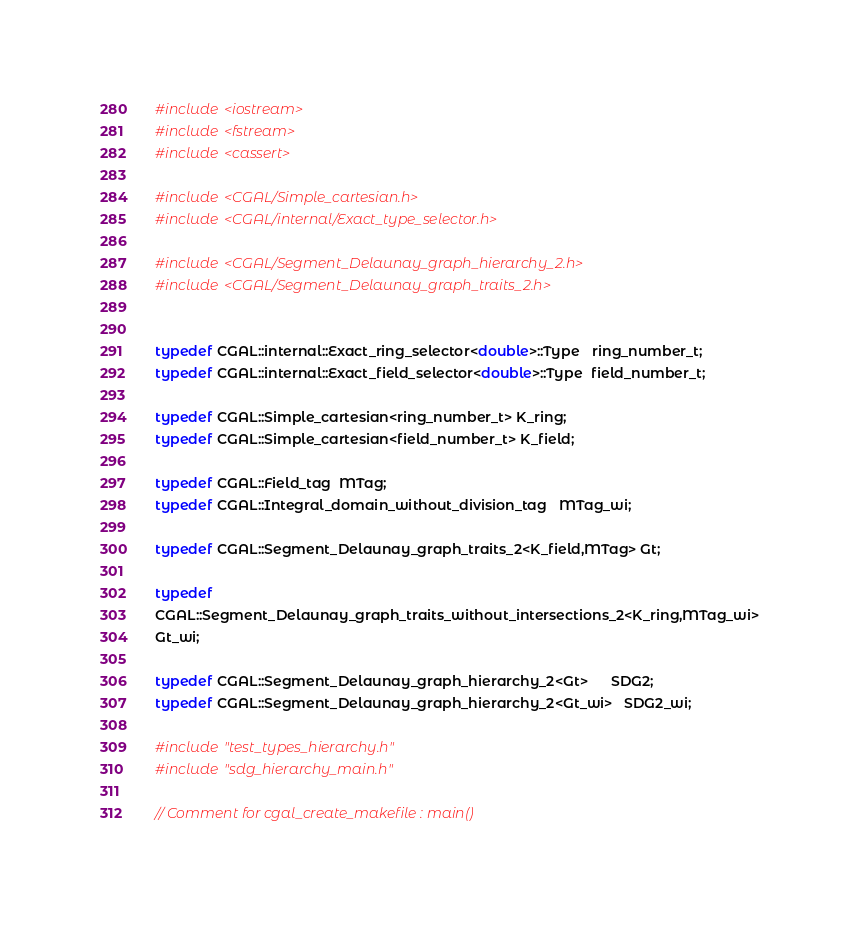<code> <loc_0><loc_0><loc_500><loc_500><_C++_>#include <iostream>
#include <fstream>
#include <cassert>

#include <CGAL/Simple_cartesian.h>
#include <CGAL/internal/Exact_type_selector.h>

#include <CGAL/Segment_Delaunay_graph_hierarchy_2.h>
#include <CGAL/Segment_Delaunay_graph_traits_2.h>


typedef CGAL::internal::Exact_ring_selector<double>::Type   ring_number_t;
typedef CGAL::internal::Exact_field_selector<double>::Type  field_number_t;

typedef CGAL::Simple_cartesian<ring_number_t> K_ring;
typedef CGAL::Simple_cartesian<field_number_t> K_field;

typedef CGAL::Field_tag  MTag;
typedef CGAL::Integral_domain_without_division_tag   MTag_wi;

typedef CGAL::Segment_Delaunay_graph_traits_2<K_field,MTag> Gt;

typedef
CGAL::Segment_Delaunay_graph_traits_without_intersections_2<K_ring,MTag_wi>
Gt_wi;

typedef CGAL::Segment_Delaunay_graph_hierarchy_2<Gt>      SDG2;
typedef CGAL::Segment_Delaunay_graph_hierarchy_2<Gt_wi>   SDG2_wi;

#include "test_types_hierarchy.h"
#include "sdg_hierarchy_main.h"

// Comment for cgal_create_makefile : main()

</code> 